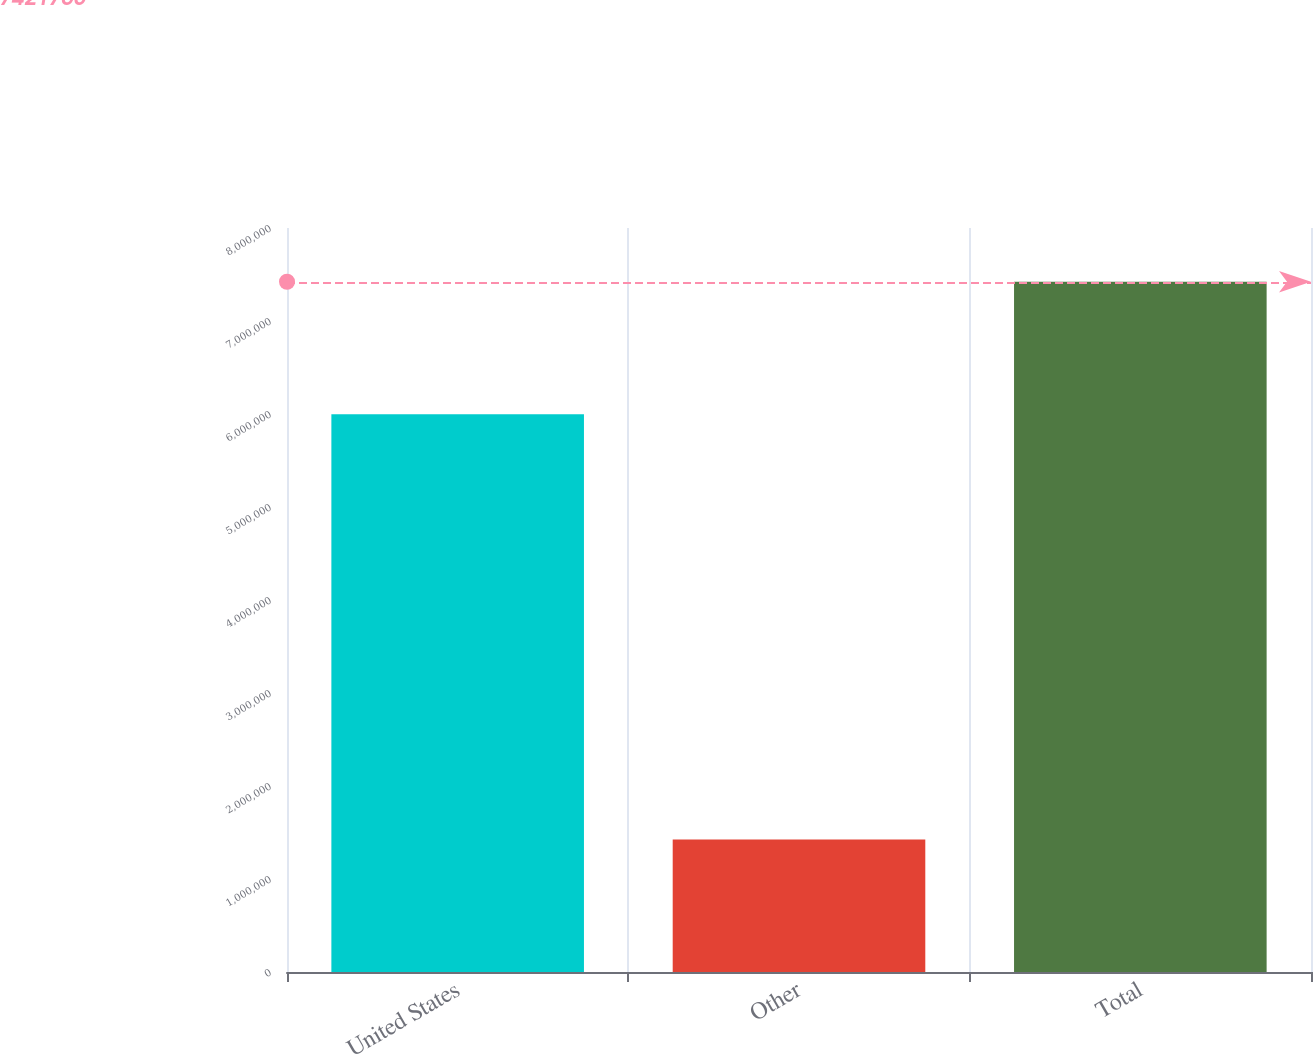Convert chart. <chart><loc_0><loc_0><loc_500><loc_500><bar_chart><fcel>United States<fcel>Other<fcel>Total<nl><fcel>5.99656e+06<fcel>1.4252e+06<fcel>7.42177e+06<nl></chart> 